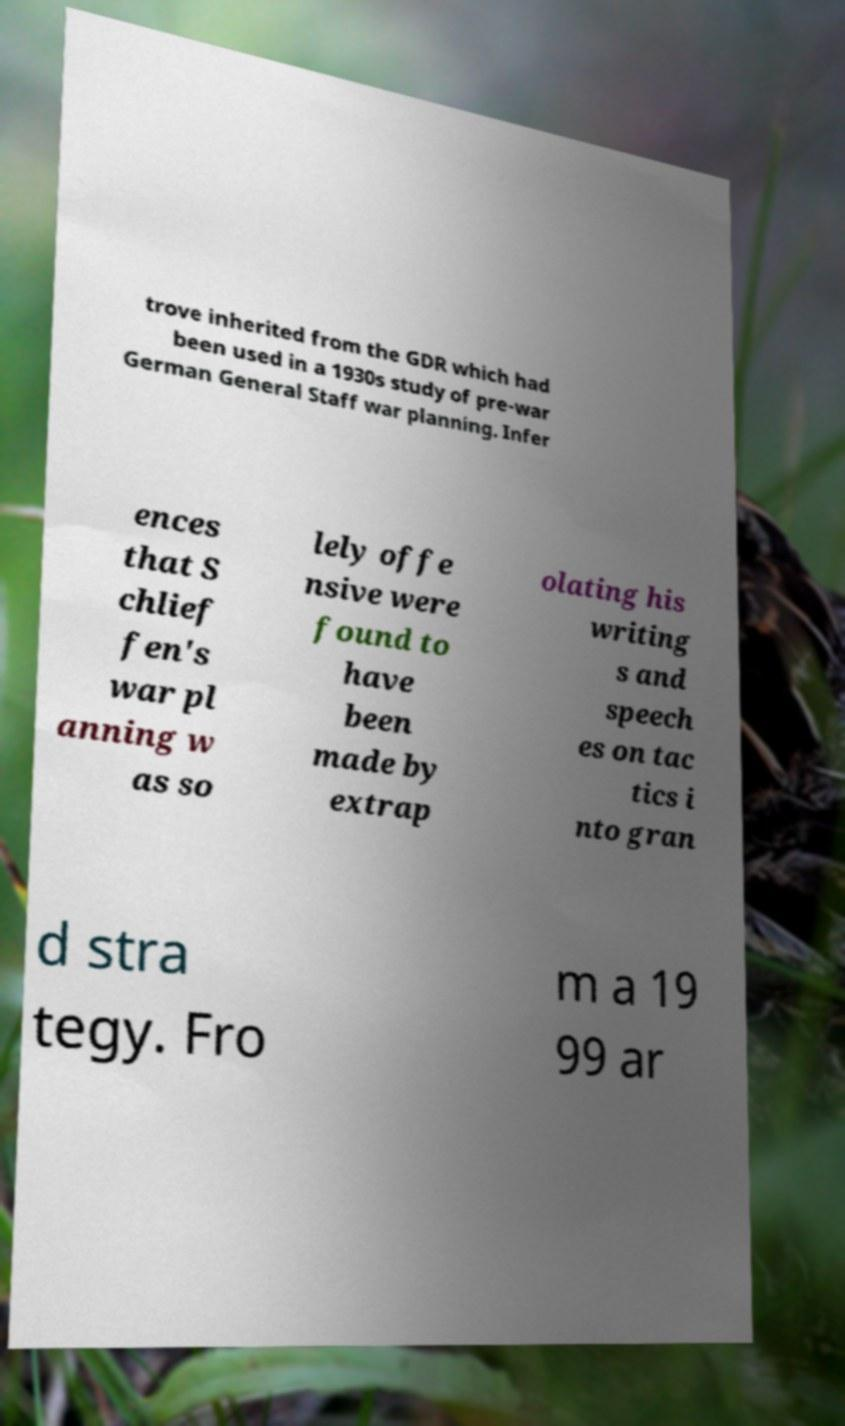For documentation purposes, I need the text within this image transcribed. Could you provide that? trove inherited from the GDR which had been used in a 1930s study of pre-war German General Staff war planning. Infer ences that S chlief fen's war pl anning w as so lely offe nsive were found to have been made by extrap olating his writing s and speech es on tac tics i nto gran d stra tegy. Fro m a 19 99 ar 